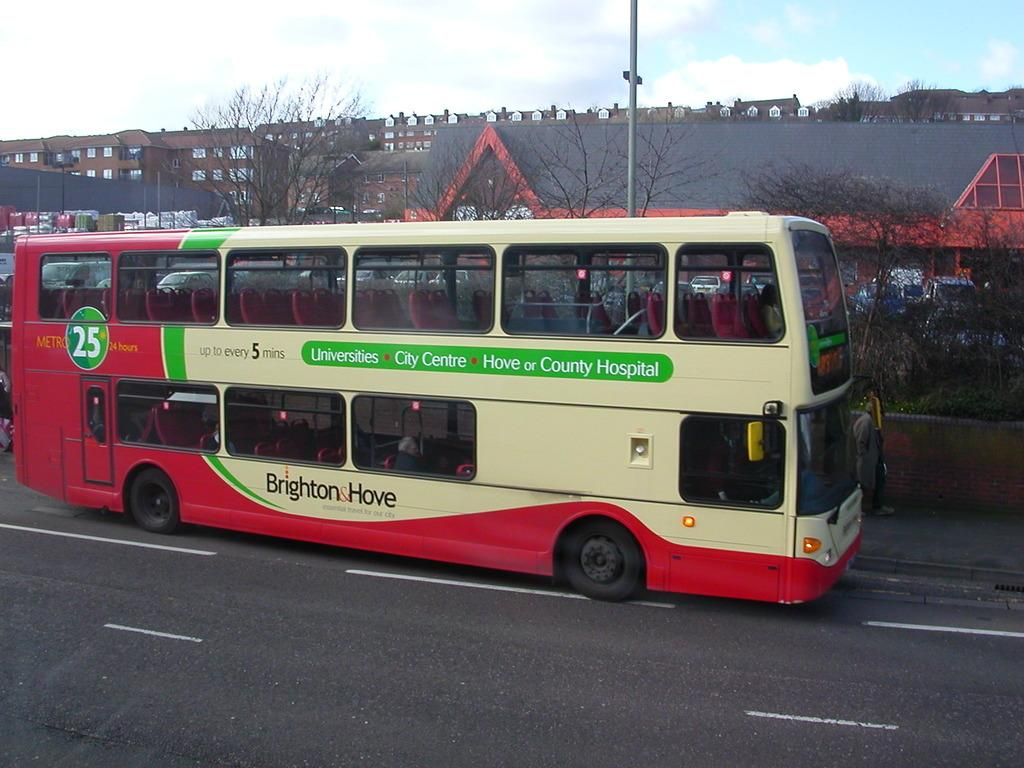<image>
Write a terse but informative summary of the picture. a bus with the number 25 on it with a label that says 'brighton & hove' on it 